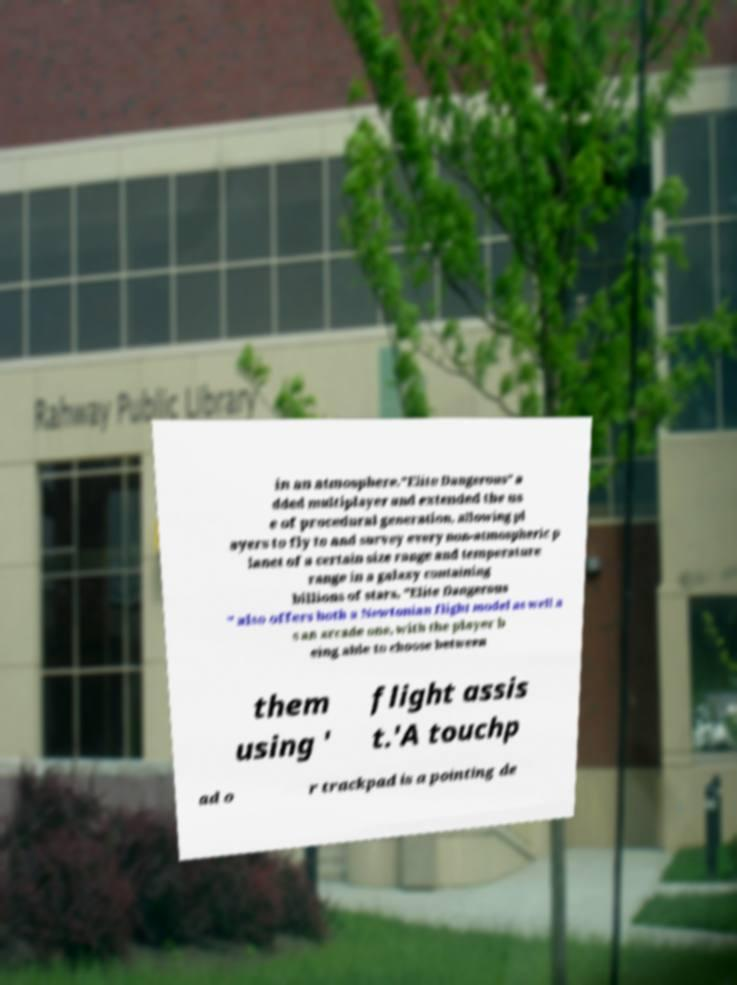Can you accurately transcribe the text from the provided image for me? in an atmosphere."Elite Dangerous" a dded multiplayer and extended the us e of procedural generation, allowing pl ayers to fly to and survey every non-atmospheric p lanet of a certain size range and temperature range in a galaxy containing billions of stars. "Elite Dangerous " also offers both a Newtonian flight model as well a s an arcade one, with the player b eing able to choose between them using ' flight assis t.'A touchp ad o r trackpad is a pointing de 